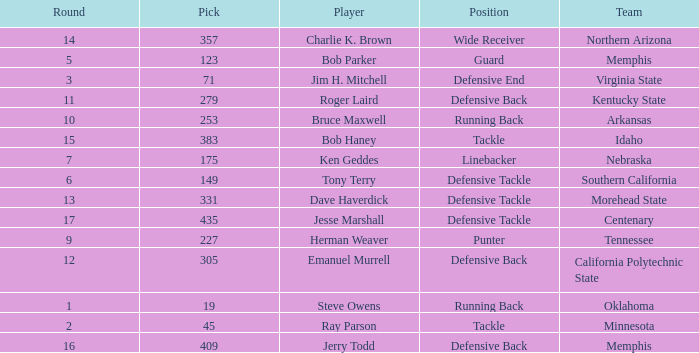What is the lowest pick of the defensive tackle player dave haverdick? 331.0. 